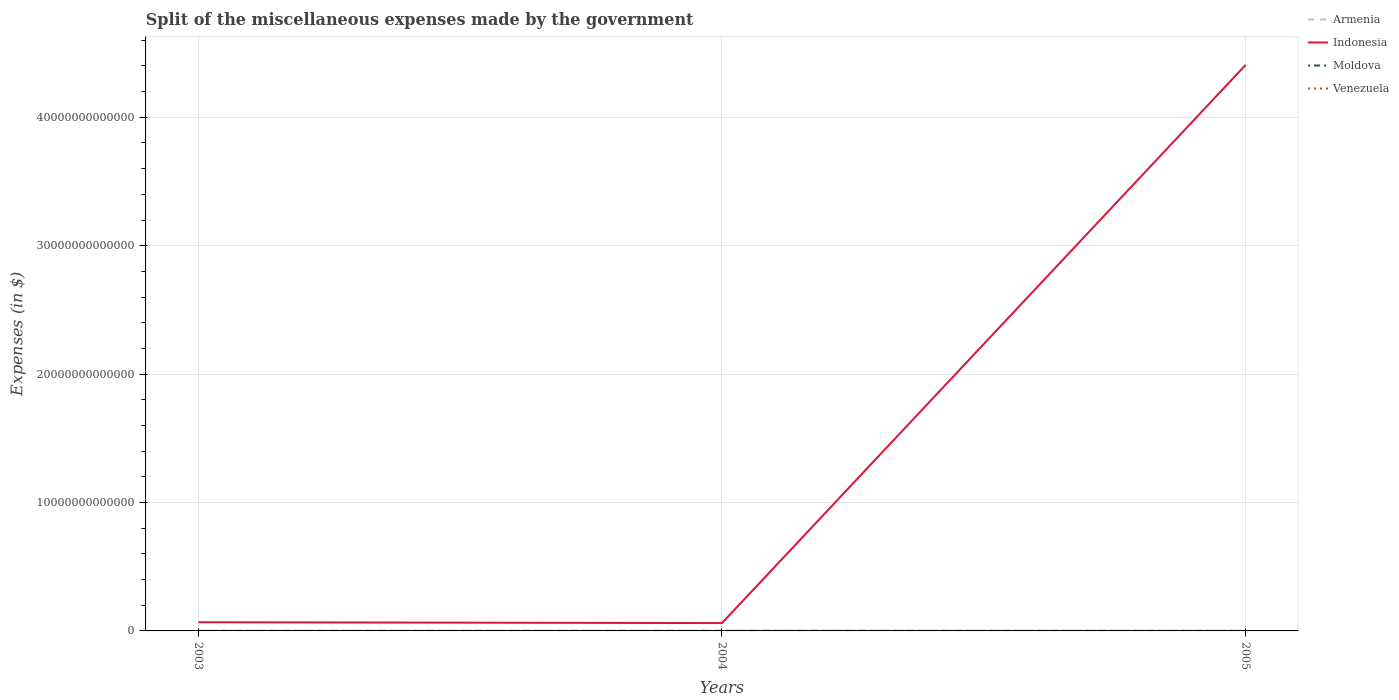Does the line corresponding to Moldova intersect with the line corresponding to Venezuela?
Your answer should be compact. Yes. Is the number of lines equal to the number of legend labels?
Your answer should be very brief. Yes. Across all years, what is the maximum miscellaneous expenses made by the government in Armenia?
Provide a succinct answer. 3.30e+09. What is the total miscellaneous expenses made by the government in Moldova in the graph?
Give a very brief answer. -3.52e+08. What is the difference between the highest and the second highest miscellaneous expenses made by the government in Moldova?
Provide a short and direct response. 6.06e+08. What is the difference between the highest and the lowest miscellaneous expenses made by the government in Armenia?
Your answer should be compact. 1. How many lines are there?
Provide a succinct answer. 4. What is the difference between two consecutive major ticks on the Y-axis?
Offer a terse response. 1.00e+13. Are the values on the major ticks of Y-axis written in scientific E-notation?
Your answer should be very brief. No. How many legend labels are there?
Your response must be concise. 4. How are the legend labels stacked?
Offer a terse response. Vertical. What is the title of the graph?
Your answer should be compact. Split of the miscellaneous expenses made by the government. Does "Antigua and Barbuda" appear as one of the legend labels in the graph?
Your answer should be very brief. No. What is the label or title of the Y-axis?
Keep it short and to the point. Expenses (in $). What is the Expenses (in $) in Armenia in 2003?
Provide a succinct answer. 1.02e+1. What is the Expenses (in $) in Indonesia in 2003?
Keep it short and to the point. 6.76e+11. What is the Expenses (in $) of Moldova in 2003?
Your answer should be very brief. 6.01e+08. What is the Expenses (in $) in Venezuela in 2003?
Your answer should be very brief. 5.27e+08. What is the Expenses (in $) of Armenia in 2004?
Provide a succinct answer. 2.00e+1. What is the Expenses (in $) of Indonesia in 2004?
Offer a terse response. 6.11e+11. What is the Expenses (in $) of Moldova in 2004?
Your answer should be very brief. 8.56e+08. What is the Expenses (in $) in Venezuela in 2004?
Give a very brief answer. 1.03e+09. What is the Expenses (in $) of Armenia in 2005?
Offer a very short reply. 3.30e+09. What is the Expenses (in $) in Indonesia in 2005?
Provide a succinct answer. 4.41e+13. What is the Expenses (in $) of Moldova in 2005?
Keep it short and to the point. 1.21e+09. What is the Expenses (in $) in Venezuela in 2005?
Offer a terse response. 2.11e+09. Across all years, what is the maximum Expenses (in $) of Armenia?
Your answer should be very brief. 2.00e+1. Across all years, what is the maximum Expenses (in $) of Indonesia?
Provide a short and direct response. 4.41e+13. Across all years, what is the maximum Expenses (in $) in Moldova?
Ensure brevity in your answer.  1.21e+09. Across all years, what is the maximum Expenses (in $) in Venezuela?
Your answer should be very brief. 2.11e+09. Across all years, what is the minimum Expenses (in $) in Armenia?
Your answer should be very brief. 3.30e+09. Across all years, what is the minimum Expenses (in $) in Indonesia?
Provide a short and direct response. 6.11e+11. Across all years, what is the minimum Expenses (in $) in Moldova?
Offer a very short reply. 6.01e+08. Across all years, what is the minimum Expenses (in $) in Venezuela?
Provide a succinct answer. 5.27e+08. What is the total Expenses (in $) in Armenia in the graph?
Your response must be concise. 3.35e+1. What is the total Expenses (in $) in Indonesia in the graph?
Your answer should be very brief. 4.54e+13. What is the total Expenses (in $) in Moldova in the graph?
Your answer should be very brief. 2.66e+09. What is the total Expenses (in $) of Venezuela in the graph?
Offer a terse response. 3.66e+09. What is the difference between the Expenses (in $) of Armenia in 2003 and that in 2004?
Your answer should be very brief. -9.85e+09. What is the difference between the Expenses (in $) of Indonesia in 2003 and that in 2004?
Offer a very short reply. 6.53e+1. What is the difference between the Expenses (in $) of Moldova in 2003 and that in 2004?
Provide a succinct answer. -2.54e+08. What is the difference between the Expenses (in $) of Venezuela in 2003 and that in 2004?
Your answer should be compact. -5.05e+08. What is the difference between the Expenses (in $) of Armenia in 2003 and that in 2005?
Your response must be concise. 6.89e+09. What is the difference between the Expenses (in $) of Indonesia in 2003 and that in 2005?
Make the answer very short. -4.34e+13. What is the difference between the Expenses (in $) of Moldova in 2003 and that in 2005?
Give a very brief answer. -6.06e+08. What is the difference between the Expenses (in $) of Venezuela in 2003 and that in 2005?
Ensure brevity in your answer.  -1.58e+09. What is the difference between the Expenses (in $) of Armenia in 2004 and that in 2005?
Offer a very short reply. 1.67e+1. What is the difference between the Expenses (in $) of Indonesia in 2004 and that in 2005?
Ensure brevity in your answer.  -4.35e+13. What is the difference between the Expenses (in $) in Moldova in 2004 and that in 2005?
Provide a succinct answer. -3.52e+08. What is the difference between the Expenses (in $) in Venezuela in 2004 and that in 2005?
Give a very brief answer. -1.07e+09. What is the difference between the Expenses (in $) in Armenia in 2003 and the Expenses (in $) in Indonesia in 2004?
Give a very brief answer. -6.01e+11. What is the difference between the Expenses (in $) of Armenia in 2003 and the Expenses (in $) of Moldova in 2004?
Make the answer very short. 9.34e+09. What is the difference between the Expenses (in $) of Armenia in 2003 and the Expenses (in $) of Venezuela in 2004?
Give a very brief answer. 9.16e+09. What is the difference between the Expenses (in $) of Indonesia in 2003 and the Expenses (in $) of Moldova in 2004?
Keep it short and to the point. 6.75e+11. What is the difference between the Expenses (in $) in Indonesia in 2003 and the Expenses (in $) in Venezuela in 2004?
Provide a succinct answer. 6.75e+11. What is the difference between the Expenses (in $) in Moldova in 2003 and the Expenses (in $) in Venezuela in 2004?
Provide a short and direct response. -4.30e+08. What is the difference between the Expenses (in $) in Armenia in 2003 and the Expenses (in $) in Indonesia in 2005?
Offer a terse response. -4.41e+13. What is the difference between the Expenses (in $) of Armenia in 2003 and the Expenses (in $) of Moldova in 2005?
Give a very brief answer. 8.98e+09. What is the difference between the Expenses (in $) of Armenia in 2003 and the Expenses (in $) of Venezuela in 2005?
Provide a short and direct response. 8.09e+09. What is the difference between the Expenses (in $) of Indonesia in 2003 and the Expenses (in $) of Moldova in 2005?
Keep it short and to the point. 6.75e+11. What is the difference between the Expenses (in $) of Indonesia in 2003 and the Expenses (in $) of Venezuela in 2005?
Offer a terse response. 6.74e+11. What is the difference between the Expenses (in $) of Moldova in 2003 and the Expenses (in $) of Venezuela in 2005?
Provide a short and direct response. -1.50e+09. What is the difference between the Expenses (in $) in Armenia in 2004 and the Expenses (in $) in Indonesia in 2005?
Your response must be concise. -4.41e+13. What is the difference between the Expenses (in $) in Armenia in 2004 and the Expenses (in $) in Moldova in 2005?
Your answer should be very brief. 1.88e+1. What is the difference between the Expenses (in $) in Armenia in 2004 and the Expenses (in $) in Venezuela in 2005?
Make the answer very short. 1.79e+1. What is the difference between the Expenses (in $) in Indonesia in 2004 and the Expenses (in $) in Moldova in 2005?
Offer a terse response. 6.10e+11. What is the difference between the Expenses (in $) of Indonesia in 2004 and the Expenses (in $) of Venezuela in 2005?
Ensure brevity in your answer.  6.09e+11. What is the difference between the Expenses (in $) in Moldova in 2004 and the Expenses (in $) in Venezuela in 2005?
Keep it short and to the point. -1.25e+09. What is the average Expenses (in $) of Armenia per year?
Provide a succinct answer. 1.12e+1. What is the average Expenses (in $) of Indonesia per year?
Offer a terse response. 1.51e+13. What is the average Expenses (in $) of Moldova per year?
Give a very brief answer. 8.88e+08. What is the average Expenses (in $) of Venezuela per year?
Ensure brevity in your answer.  1.22e+09. In the year 2003, what is the difference between the Expenses (in $) in Armenia and Expenses (in $) in Indonesia?
Give a very brief answer. -6.66e+11. In the year 2003, what is the difference between the Expenses (in $) of Armenia and Expenses (in $) of Moldova?
Offer a terse response. 9.59e+09. In the year 2003, what is the difference between the Expenses (in $) of Armenia and Expenses (in $) of Venezuela?
Offer a very short reply. 9.66e+09. In the year 2003, what is the difference between the Expenses (in $) of Indonesia and Expenses (in $) of Moldova?
Offer a terse response. 6.76e+11. In the year 2003, what is the difference between the Expenses (in $) in Indonesia and Expenses (in $) in Venezuela?
Keep it short and to the point. 6.76e+11. In the year 2003, what is the difference between the Expenses (in $) in Moldova and Expenses (in $) in Venezuela?
Provide a succinct answer. 7.48e+07. In the year 2004, what is the difference between the Expenses (in $) in Armenia and Expenses (in $) in Indonesia?
Your response must be concise. -5.91e+11. In the year 2004, what is the difference between the Expenses (in $) in Armenia and Expenses (in $) in Moldova?
Offer a very short reply. 1.92e+1. In the year 2004, what is the difference between the Expenses (in $) in Armenia and Expenses (in $) in Venezuela?
Give a very brief answer. 1.90e+1. In the year 2004, what is the difference between the Expenses (in $) of Indonesia and Expenses (in $) of Moldova?
Provide a short and direct response. 6.10e+11. In the year 2004, what is the difference between the Expenses (in $) in Indonesia and Expenses (in $) in Venezuela?
Your answer should be very brief. 6.10e+11. In the year 2004, what is the difference between the Expenses (in $) in Moldova and Expenses (in $) in Venezuela?
Offer a terse response. -1.76e+08. In the year 2005, what is the difference between the Expenses (in $) of Armenia and Expenses (in $) of Indonesia?
Offer a terse response. -4.41e+13. In the year 2005, what is the difference between the Expenses (in $) of Armenia and Expenses (in $) of Moldova?
Your response must be concise. 2.10e+09. In the year 2005, what is the difference between the Expenses (in $) in Armenia and Expenses (in $) in Venezuela?
Ensure brevity in your answer.  1.20e+09. In the year 2005, what is the difference between the Expenses (in $) of Indonesia and Expenses (in $) of Moldova?
Your answer should be very brief. 4.41e+13. In the year 2005, what is the difference between the Expenses (in $) of Indonesia and Expenses (in $) of Venezuela?
Keep it short and to the point. 4.41e+13. In the year 2005, what is the difference between the Expenses (in $) of Moldova and Expenses (in $) of Venezuela?
Give a very brief answer. -8.99e+08. What is the ratio of the Expenses (in $) in Armenia in 2003 to that in 2004?
Your response must be concise. 0.51. What is the ratio of the Expenses (in $) of Indonesia in 2003 to that in 2004?
Your answer should be very brief. 1.11. What is the ratio of the Expenses (in $) of Moldova in 2003 to that in 2004?
Make the answer very short. 0.7. What is the ratio of the Expenses (in $) in Venezuela in 2003 to that in 2004?
Make the answer very short. 0.51. What is the ratio of the Expenses (in $) of Armenia in 2003 to that in 2005?
Offer a very short reply. 3.08. What is the ratio of the Expenses (in $) of Indonesia in 2003 to that in 2005?
Your response must be concise. 0.02. What is the ratio of the Expenses (in $) of Moldova in 2003 to that in 2005?
Provide a short and direct response. 0.5. What is the ratio of the Expenses (in $) of Armenia in 2004 to that in 2005?
Your response must be concise. 6.07. What is the ratio of the Expenses (in $) of Indonesia in 2004 to that in 2005?
Provide a short and direct response. 0.01. What is the ratio of the Expenses (in $) of Moldova in 2004 to that in 2005?
Offer a very short reply. 0.71. What is the ratio of the Expenses (in $) of Venezuela in 2004 to that in 2005?
Provide a short and direct response. 0.49. What is the difference between the highest and the second highest Expenses (in $) of Armenia?
Keep it short and to the point. 9.85e+09. What is the difference between the highest and the second highest Expenses (in $) in Indonesia?
Keep it short and to the point. 4.34e+13. What is the difference between the highest and the second highest Expenses (in $) of Moldova?
Offer a very short reply. 3.52e+08. What is the difference between the highest and the second highest Expenses (in $) of Venezuela?
Ensure brevity in your answer.  1.07e+09. What is the difference between the highest and the lowest Expenses (in $) in Armenia?
Your response must be concise. 1.67e+1. What is the difference between the highest and the lowest Expenses (in $) of Indonesia?
Provide a short and direct response. 4.35e+13. What is the difference between the highest and the lowest Expenses (in $) of Moldova?
Offer a terse response. 6.06e+08. What is the difference between the highest and the lowest Expenses (in $) in Venezuela?
Ensure brevity in your answer.  1.58e+09. 